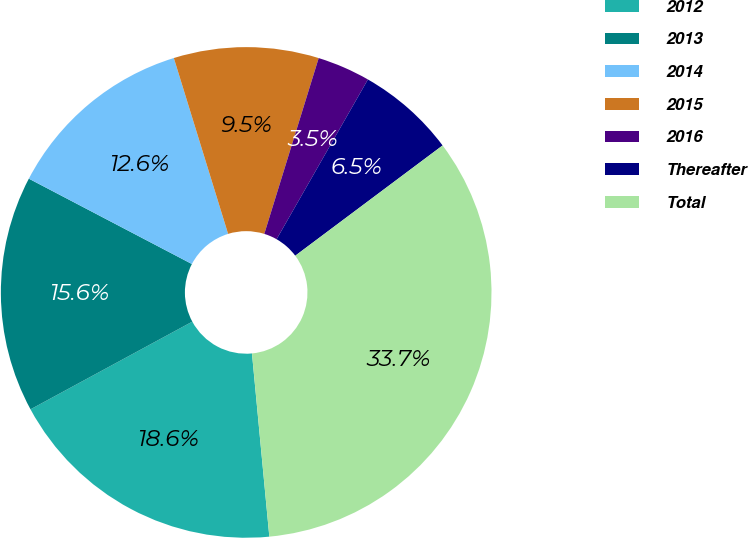<chart> <loc_0><loc_0><loc_500><loc_500><pie_chart><fcel>2012<fcel>2013<fcel>2014<fcel>2015<fcel>2016<fcel>Thereafter<fcel>Total<nl><fcel>18.6%<fcel>15.58%<fcel>12.56%<fcel>9.54%<fcel>3.49%<fcel>6.51%<fcel>33.72%<nl></chart> 